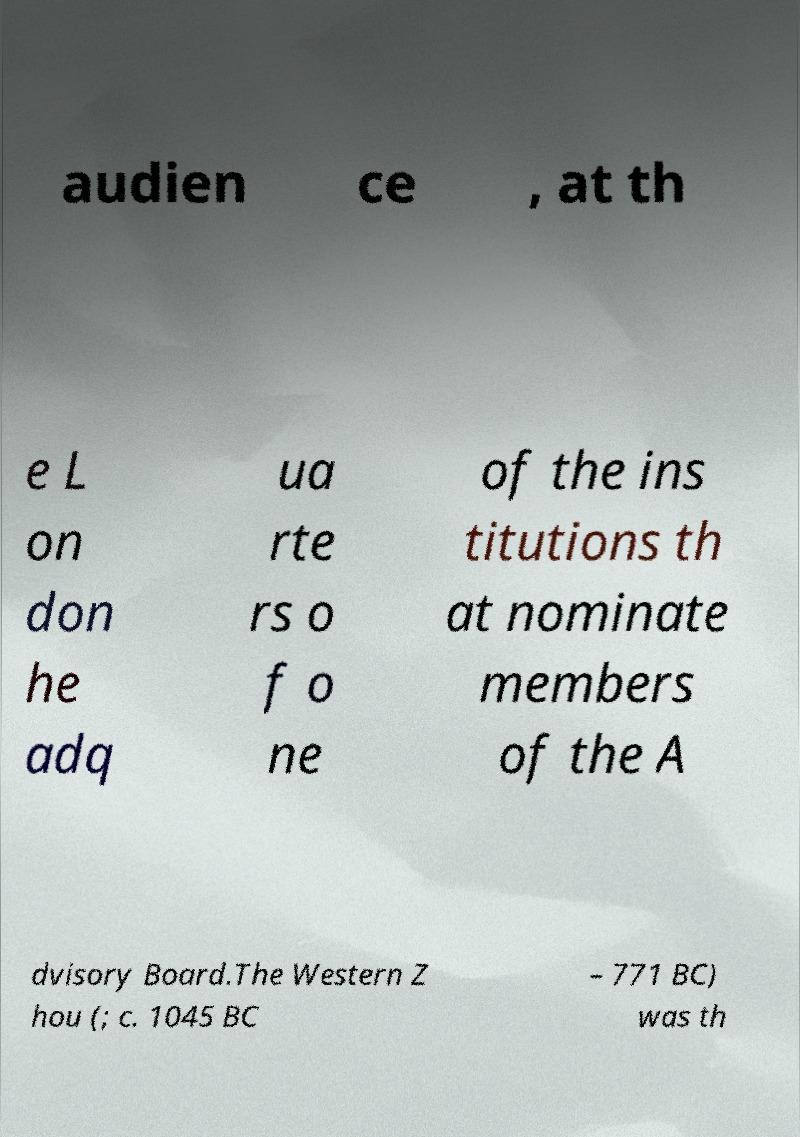Can you read and provide the text displayed in the image?This photo seems to have some interesting text. Can you extract and type it out for me? audien ce , at th e L on don he adq ua rte rs o f o ne of the ins titutions th at nominate members of the A dvisory Board.The Western Z hou (; c. 1045 BC – 771 BC) was th 